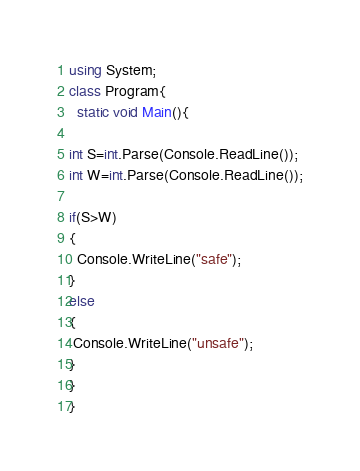Convert code to text. <code><loc_0><loc_0><loc_500><loc_500><_C#_>using System;
class Program{
  static void Main(){
 
int S=int.Parse(Console.ReadLine());
int W=int.Parse(Console.ReadLine());
 
if(S>W)
{
  Console.WriteLine("safe");
}
else
{
 Console.WriteLine("unsafe");
}
} 
}</code> 